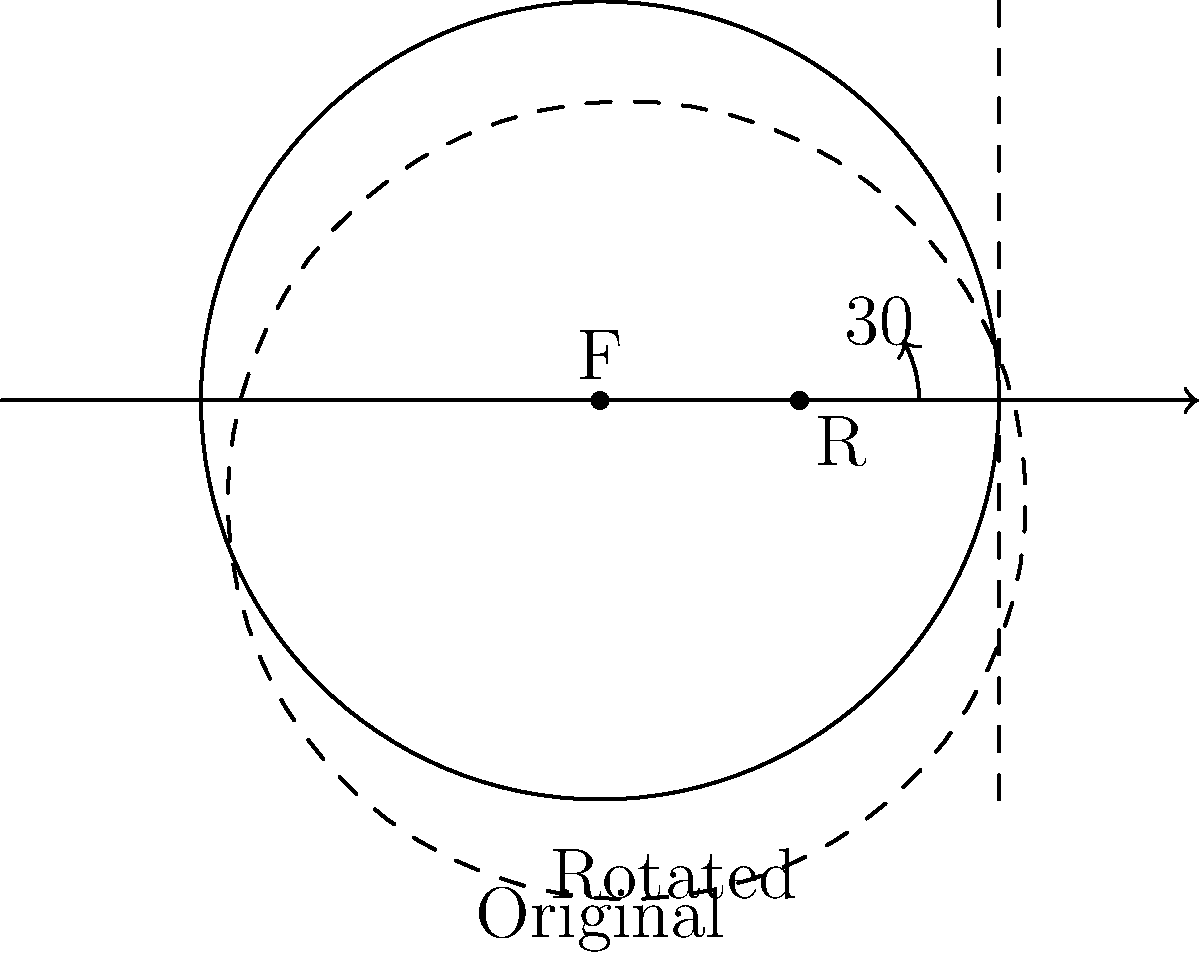A camera lens is rotated 30° clockwise around point R, which is located 0.5 units to the right of the focal point F on the optical axis. If the original lens has a radius of 1 unit, what is the distance between the center of the original lens and the center of the rotated lens? To solve this problem, we need to follow these steps:

1) The center of the original lens is at the origin (0,0).

2) The rotation point R is at (0.5,0).

3) When we rotate the lens 30° clockwise around R, the center of the lens will move in a circular path around R.

4) The radius of this circular path is the distance from R to the center of the original lens, which is 0.5 units.

5) We can find the new position of the lens center using trigonometry:
   x = 0.5 - 0.5 * cos(30°)
   y = -0.5 * sin(30°)

6) The distance between two points (x1,y1) and (x2,y2) is given by the formula:
   $$d = \sqrt{(x2-x1)^2 + (y2-y1)^2}$$

7) In this case:
   (x1,y1) = (0,0)
   (x2,y2) = (0.5 - 0.5*cos(30°), -0.5*sin(30°))

8) Plugging these into the distance formula:
   $$d = \sqrt{(0.5 - 0.5\cos(30°))^2 + (-0.5\sin(30°))^2}$$

9) Simplifying:
   $$d = \sqrt{(0.5 - 0.5 * \frac{\sqrt{3}}{2})^2 + (-0.5 * \frac{1}{2})^2}$$
   $$d = \sqrt{(0.5 - 0.25\sqrt{3})^2 + 0.0625}$$

10) This simplifies to:
    $$d = 0.5$$
Answer: 0.5 units 